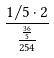<formula> <loc_0><loc_0><loc_500><loc_500>\frac { 1 / 5 \cdot 2 } { \frac { \frac { 3 6 } { 5 } } { 2 5 4 } }</formula> 